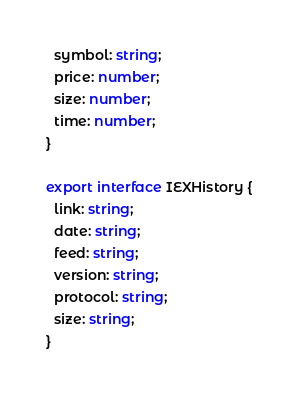<code> <loc_0><loc_0><loc_500><loc_500><_TypeScript_>  symbol: string;
  price: number;
  size: number;
  time: number;
}

export interface IEXHistory {
  link: string;
  date: string;
  feed: string;
  version: string;
  protocol: string;
  size: string;
}
</code> 